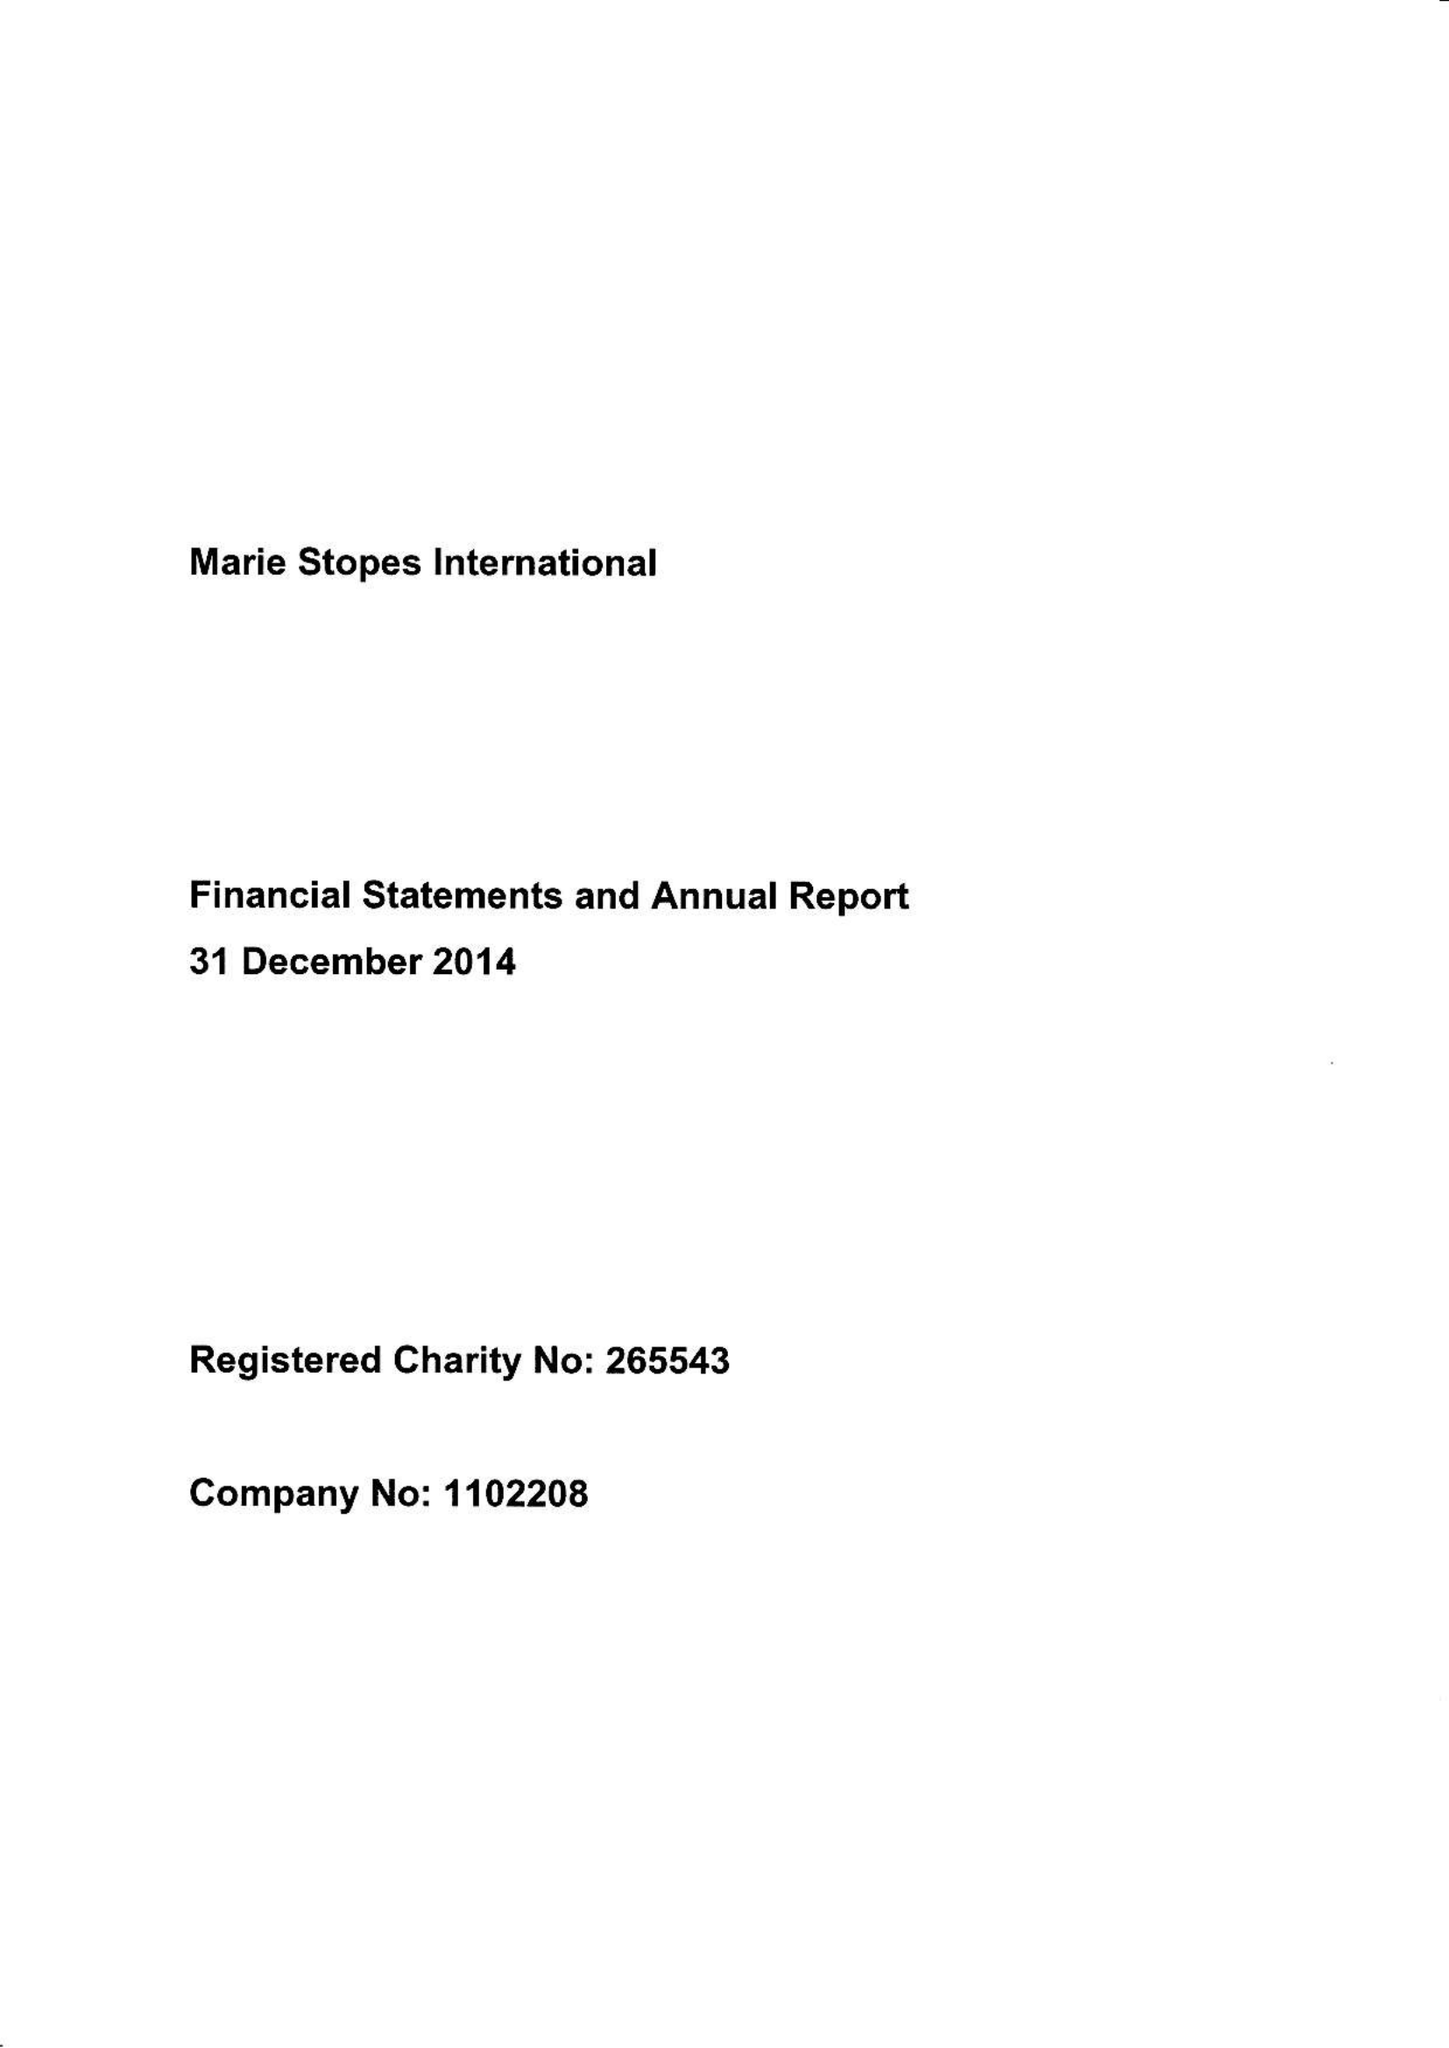What is the value for the income_annually_in_british_pounds?
Answer the question using a single word or phrase. 242004000.00 